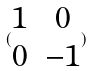Convert formula to latex. <formula><loc_0><loc_0><loc_500><loc_500>( \begin{matrix} 1 & 0 \\ 0 & - 1 \end{matrix} )</formula> 